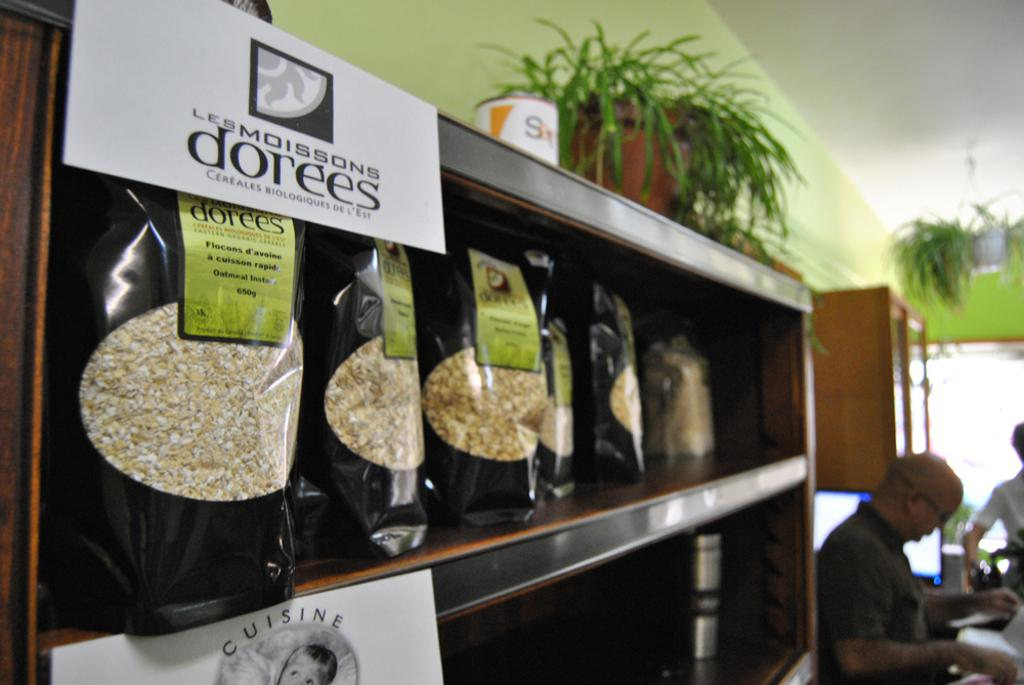What is present in the image? There are people standing in the image. What else can be seen in the image besides the people? There are packets on a rack in the image. How many frogs are playing on the rack in the image? There are no frogs present in the image, and therefore no such activity can be observed. 